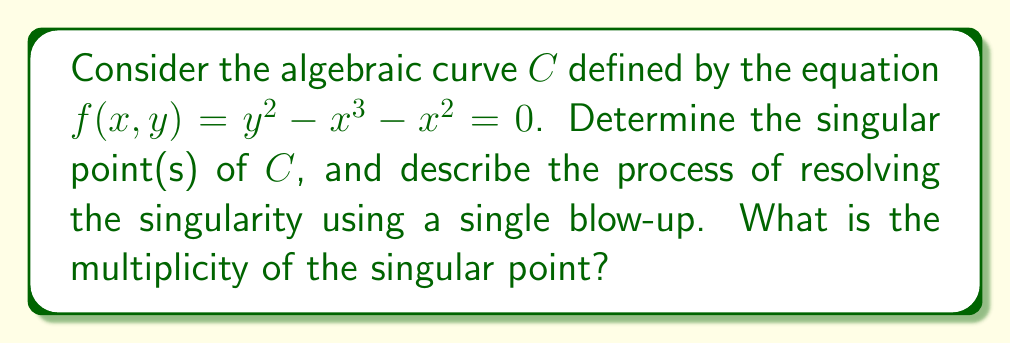Could you help me with this problem? 1. To find singular points, we need to solve the system of equations:
   $$f(x,y) = 0$$
   $$\frac{\partial f}{\partial x} = 0$$
   $$\frac{\partial f}{\partial y} = 0$$

2. Calculate partial derivatives:
   $$\frac{\partial f}{\partial x} = -3x^2 - 2x$$
   $$\frac{\partial f}{\partial y} = 2y$$

3. Solve the system:
   $$y^2 - x^3 - x^2 = 0$$
   $$-3x^2 - 2x = 0$$
   $$2y = 0$$

4. From $2y = 0$, we get $y = 0$. From $-3x^2 - 2x = 0$, we get $x(-3x - 2) = 0$, so $x = 0$ or $x = -\frac{2}{3}$.

5. Substituting these values back into $f(x,y) = 0$, we find that $(0,0)$ is the only point satisfying all equations. Thus, $(0,0)$ is the singular point.

6. To resolve the singularity, we use a blow-up transformation. Let $x = u$ and $y = uv$. Substituting into the original equation:
   $$(uv)^2 - u^3 - u^2 = 0$$

7. Factor out $u^2$:
   $$u^2(v^2 - u - 1) = 0$$

8. The strict transform is given by $v^2 - u - 1 = 0$, which is smooth.

9. To find the multiplicity, we examine the Taylor expansion of $f(x,y)$ around $(0,0)$:
   $$f(x,y) = y^2 - x^3 - x^2 = y^2 - x^2 + \text{higher order terms}$$

10. The lowest degree terms are quadratic, so the multiplicity of the singular point is 2.
Answer: Singular point: $(0,0)$; Multiplicity: 2 